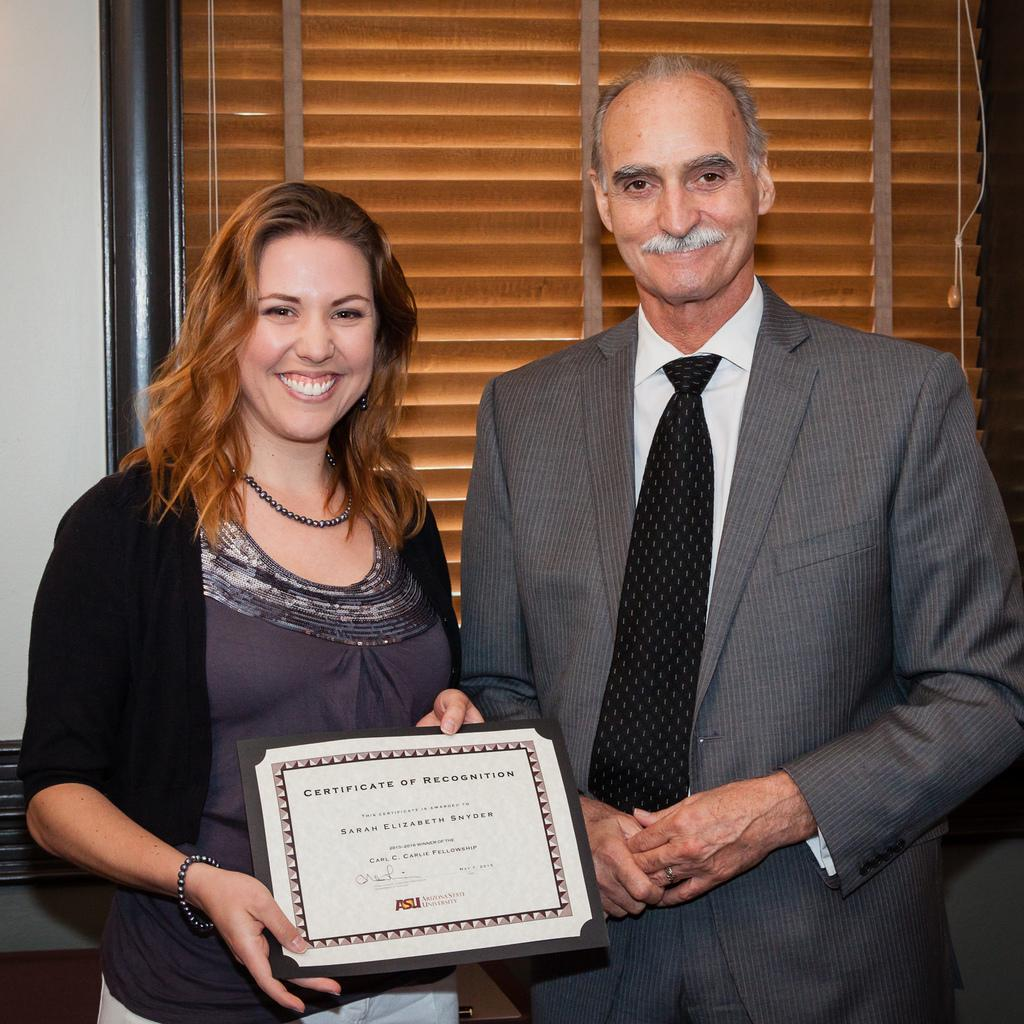How many people are in the image? There are two persons standing in the image. What is the facial expression of the people in the image? Both persons are smiling. Can you describe what one of the persons is holding? One person is holding an object. What can be seen in the background of the image? There is a wall and a shutter in the background of the image. What type of pest can be seen causing trouble in the image? There is no pest or trouble present in the image; it features two smiling people and a background with a wall and a shutter. 